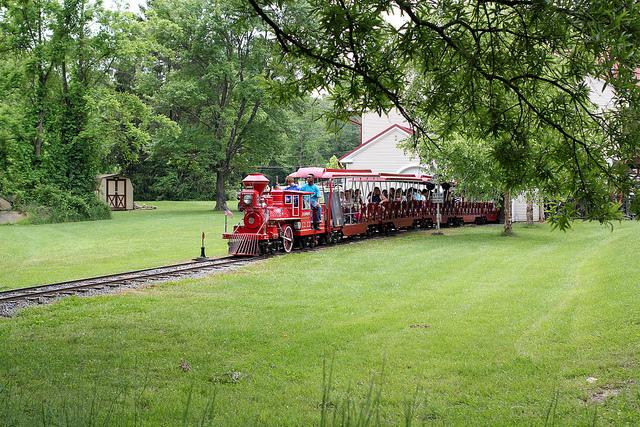Are the passengers on the train?
Quick response, please. Yes. Is there a shed in the background?
Write a very short answer. Yes. What type of vehicle is this?
Short answer required. Train. Is a normal train?
Answer briefly. No. 